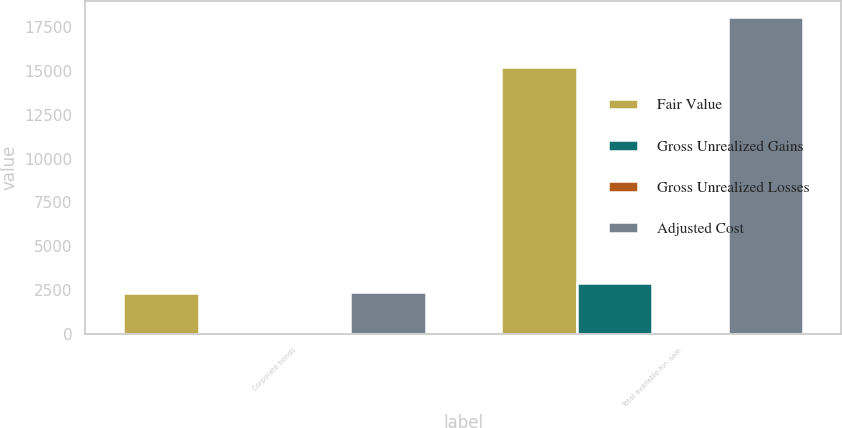<chart> <loc_0><loc_0><loc_500><loc_500><stacked_bar_chart><ecel><fcel>Corporate bonds<fcel>Total available-for- sale<nl><fcel>Fair Value<fcel>2359<fcel>15191<nl><fcel>Gross Unrealized Gains<fcel>15<fcel>2902<nl><fcel>Gross Unrealized Losses<fcel>3<fcel>7<nl><fcel>Adjusted Cost<fcel>2371<fcel>18086<nl></chart> 